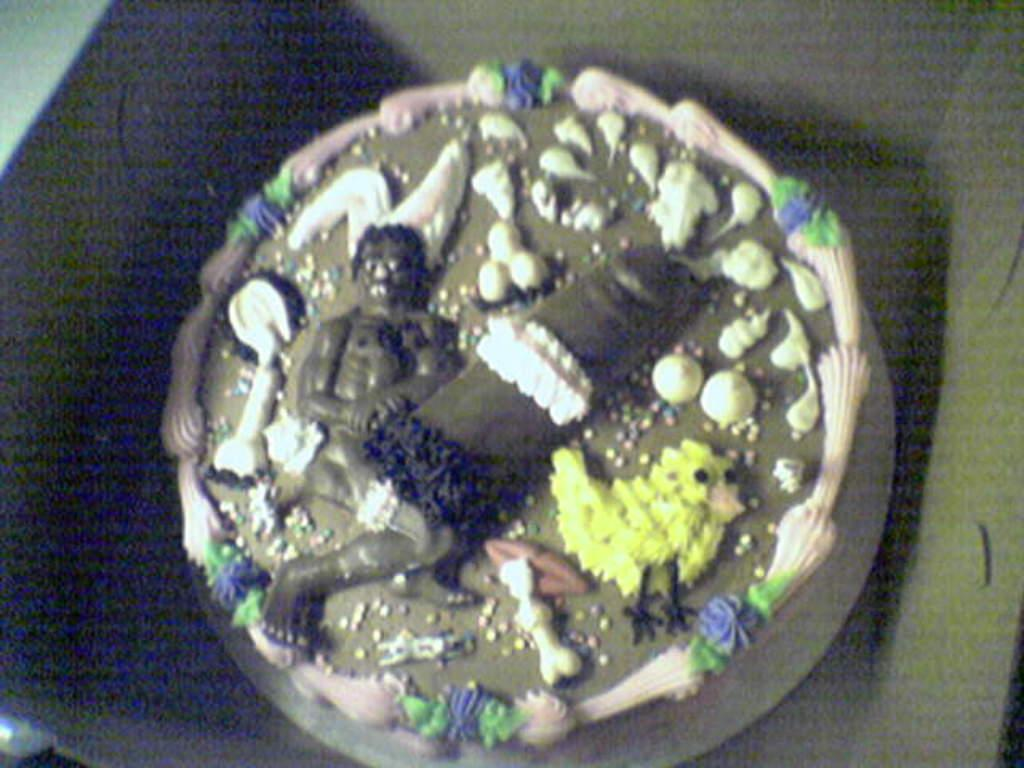What is the main subject of the image? The main subject of the image is a cake. Where is the cake located in the image? The cake is in a box. Is the cake sinking in quicksand in the image? No, there is no quicksand present in the image, and the cake is in a box. Can you see the ocean in the background of the image? No, there is no ocean visible in the image; it only features a cake in a box. 